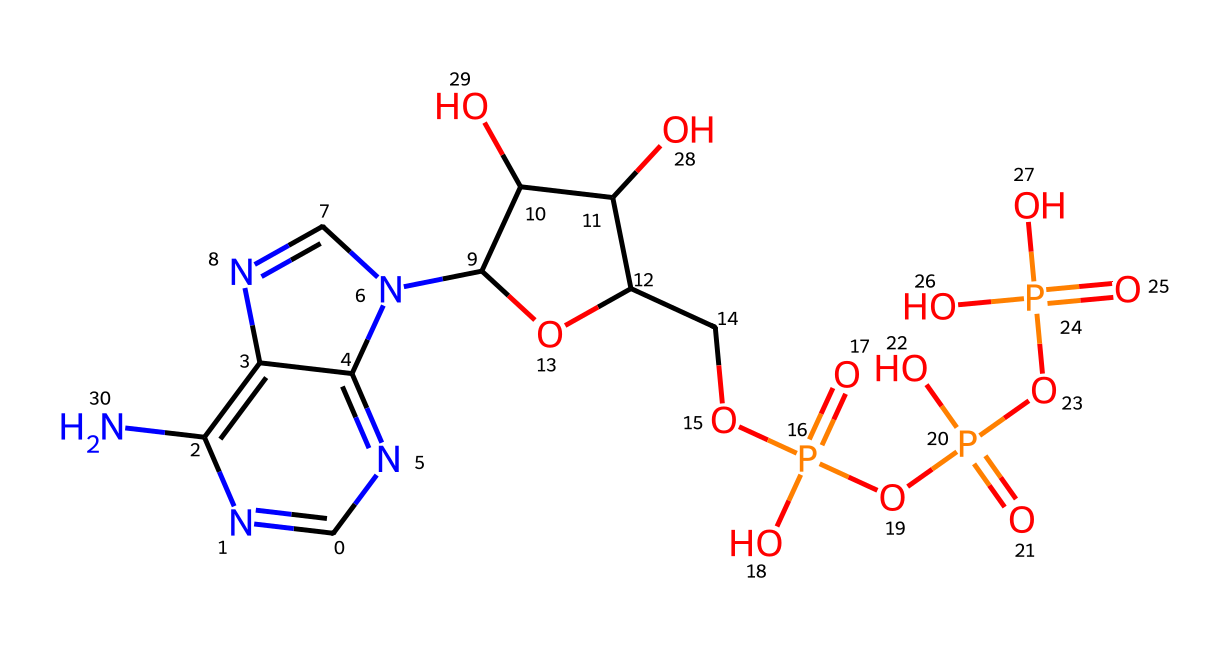What is the total number of phosphorus atoms in ATP? The structure of ATP includes three phosphate groups as evidenced by the presence of "P(=O)(O)" units. Thus, there are three phosphorus atoms in ATP.
Answer: three How many nitrogen atoms are present in the chemical structure of ATP? By examining the SMILES representation, we can count the nitrogen atoms. There are four "N" atoms present, indicating that ATP has four nitrogen atoms.
Answer: four What is the molecular formula of ATP? We can derive the molecular formula by counting the atoms in the structure: there are 10 hydrogen (H), 14 oxygen (O), 5 carbon (C), 4 nitrogen (N), and 3 phosphorus (P) atoms. Thus, the molecular formula is C10H14N5O13P3.
Answer: C10H14N5O13P3 How many total oxygen atoms are found in ATP? By analyzing the structure, we see there are a total of 13 oxygen atoms present based on the multiple "O" notations.
Answer: thirteen What type of chemical compound is ATP classified as? ATP is classified as a nucleotide because it consists of a nitrogenous base (adenine), a ribose sugar, and phosphate groups. This combination defines its classification.
Answer: nucleotide What role does ATP serve in cellular processes? ATP acts as the primary energy currency in cells, providing energy for various biochemical reactions necessary for cellular functions.
Answer: energy currency Which part of ATP contributes to its high-energy characteristics? The high-energy characteristics are mainly due to the phosphate groups because they are negatively charged and repel each other, making their bond breaking and formation energetically favorable.
Answer: phosphate groups 